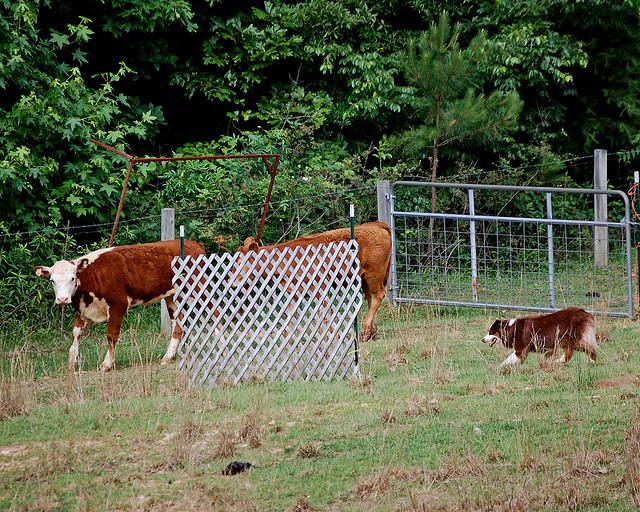What is the dog doing?
Quick response, please. Herding. How many cows are in the picture?
Be succinct. 2. Do the cows realize that there is a gate?
Give a very brief answer. Yes. What color is the small cow?
Quick response, please. Brown. Is the gate open?
Be succinct. No. How many horns does the animal on the left have?
Quick response, please. 0. 